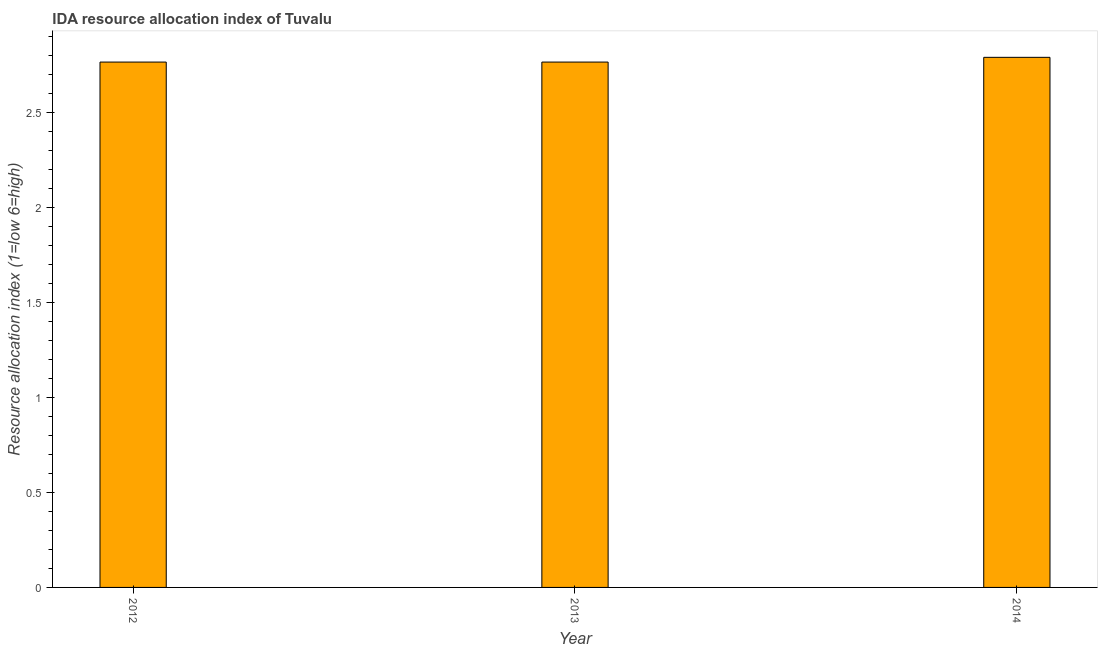Does the graph contain any zero values?
Offer a terse response. No. Does the graph contain grids?
Provide a succinct answer. No. What is the title of the graph?
Your answer should be compact. IDA resource allocation index of Tuvalu. What is the label or title of the X-axis?
Your answer should be very brief. Year. What is the label or title of the Y-axis?
Your answer should be very brief. Resource allocation index (1=low 6=high). What is the ida resource allocation index in 2013?
Give a very brief answer. 2.77. Across all years, what is the maximum ida resource allocation index?
Keep it short and to the point. 2.79. Across all years, what is the minimum ida resource allocation index?
Your response must be concise. 2.77. In which year was the ida resource allocation index maximum?
Provide a succinct answer. 2014. What is the sum of the ida resource allocation index?
Offer a terse response. 8.33. What is the difference between the ida resource allocation index in 2012 and 2013?
Provide a short and direct response. 0. What is the average ida resource allocation index per year?
Offer a very short reply. 2.77. What is the median ida resource allocation index?
Make the answer very short. 2.77. What is the ratio of the ida resource allocation index in 2012 to that in 2014?
Offer a very short reply. 0.99. Is the ida resource allocation index in 2013 less than that in 2014?
Keep it short and to the point. Yes. What is the difference between the highest and the second highest ida resource allocation index?
Keep it short and to the point. 0.03. Is the sum of the ida resource allocation index in 2013 and 2014 greater than the maximum ida resource allocation index across all years?
Provide a succinct answer. Yes. What is the difference between the highest and the lowest ida resource allocation index?
Make the answer very short. 0.03. In how many years, is the ida resource allocation index greater than the average ida resource allocation index taken over all years?
Make the answer very short. 1. Are all the bars in the graph horizontal?
Provide a succinct answer. No. How many years are there in the graph?
Your answer should be very brief. 3. Are the values on the major ticks of Y-axis written in scientific E-notation?
Your answer should be very brief. No. What is the Resource allocation index (1=low 6=high) of 2012?
Give a very brief answer. 2.77. What is the Resource allocation index (1=low 6=high) of 2013?
Your answer should be compact. 2.77. What is the Resource allocation index (1=low 6=high) in 2014?
Ensure brevity in your answer.  2.79. What is the difference between the Resource allocation index (1=low 6=high) in 2012 and 2014?
Keep it short and to the point. -0.03. What is the difference between the Resource allocation index (1=low 6=high) in 2013 and 2014?
Provide a succinct answer. -0.03. What is the ratio of the Resource allocation index (1=low 6=high) in 2013 to that in 2014?
Offer a terse response. 0.99. 